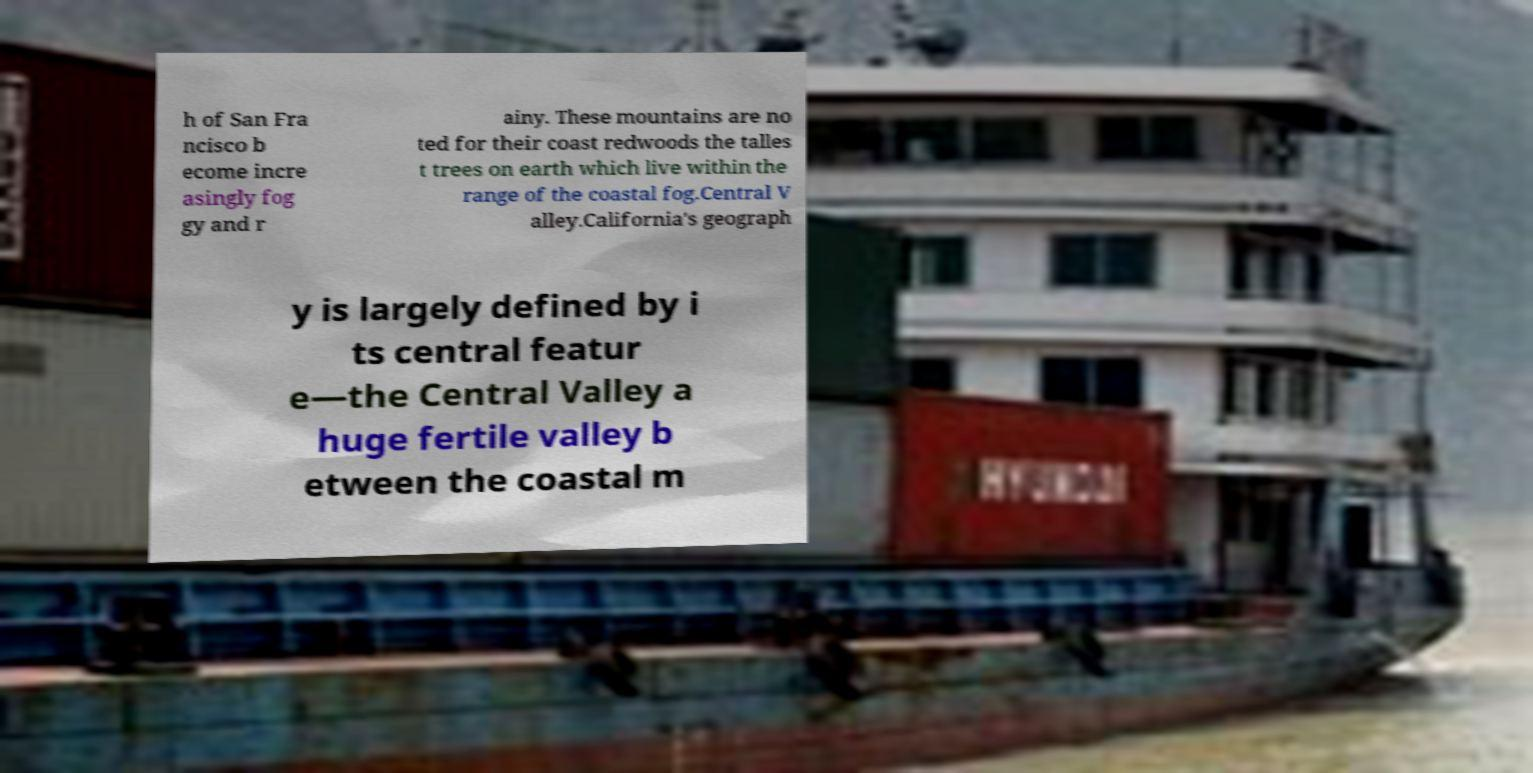I need the written content from this picture converted into text. Can you do that? h of San Fra ncisco b ecome incre asingly fog gy and r ainy. These mountains are no ted for their coast redwoods the talles t trees on earth which live within the range of the coastal fog.Central V alley.California's geograph y is largely defined by i ts central featur e—the Central Valley a huge fertile valley b etween the coastal m 